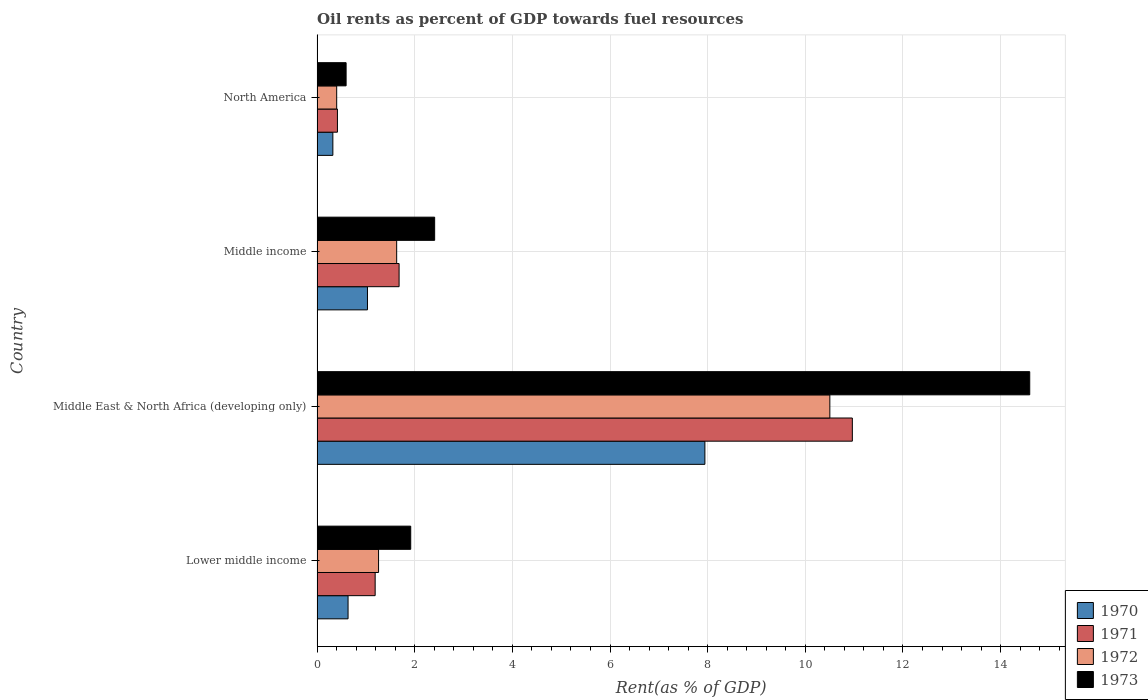How many bars are there on the 2nd tick from the top?
Provide a short and direct response. 4. How many bars are there on the 4th tick from the bottom?
Your answer should be very brief. 4. What is the label of the 4th group of bars from the top?
Your answer should be very brief. Lower middle income. What is the oil rent in 1970 in Lower middle income?
Your response must be concise. 0.63. Across all countries, what is the maximum oil rent in 1973?
Provide a short and direct response. 14.6. Across all countries, what is the minimum oil rent in 1972?
Provide a succinct answer. 0.4. In which country was the oil rent in 1973 maximum?
Offer a very short reply. Middle East & North Africa (developing only). In which country was the oil rent in 1971 minimum?
Your response must be concise. North America. What is the total oil rent in 1970 in the graph?
Give a very brief answer. 9.93. What is the difference between the oil rent in 1970 in Lower middle income and that in North America?
Provide a short and direct response. 0.31. What is the difference between the oil rent in 1973 in North America and the oil rent in 1971 in Middle East & North Africa (developing only)?
Your answer should be compact. -10.37. What is the average oil rent in 1970 per country?
Offer a terse response. 2.48. What is the difference between the oil rent in 1971 and oil rent in 1972 in North America?
Keep it short and to the point. 0.02. In how many countries, is the oil rent in 1972 greater than 7.6 %?
Provide a short and direct response. 1. What is the ratio of the oil rent in 1970 in Lower middle income to that in Middle East & North Africa (developing only)?
Offer a terse response. 0.08. What is the difference between the highest and the second highest oil rent in 1973?
Make the answer very short. 12.19. What is the difference between the highest and the lowest oil rent in 1972?
Keep it short and to the point. 10.1. Is the sum of the oil rent in 1971 in Lower middle income and North America greater than the maximum oil rent in 1972 across all countries?
Keep it short and to the point. No. Is it the case that in every country, the sum of the oil rent in 1973 and oil rent in 1972 is greater than the sum of oil rent in 1971 and oil rent in 1970?
Offer a terse response. No. What does the 1st bar from the top in Middle East & North Africa (developing only) represents?
Provide a succinct answer. 1973. How many bars are there?
Provide a succinct answer. 16. Does the graph contain grids?
Your answer should be very brief. Yes. What is the title of the graph?
Keep it short and to the point. Oil rents as percent of GDP towards fuel resources. Does "2007" appear as one of the legend labels in the graph?
Offer a very short reply. No. What is the label or title of the X-axis?
Make the answer very short. Rent(as % of GDP). What is the label or title of the Y-axis?
Offer a very short reply. Country. What is the Rent(as % of GDP) of 1970 in Lower middle income?
Provide a short and direct response. 0.63. What is the Rent(as % of GDP) of 1971 in Lower middle income?
Keep it short and to the point. 1.19. What is the Rent(as % of GDP) of 1972 in Lower middle income?
Give a very brief answer. 1.26. What is the Rent(as % of GDP) in 1973 in Lower middle income?
Your answer should be very brief. 1.92. What is the Rent(as % of GDP) of 1970 in Middle East & North Africa (developing only)?
Make the answer very short. 7.94. What is the Rent(as % of GDP) in 1971 in Middle East & North Africa (developing only)?
Keep it short and to the point. 10.96. What is the Rent(as % of GDP) of 1972 in Middle East & North Africa (developing only)?
Offer a very short reply. 10.5. What is the Rent(as % of GDP) in 1973 in Middle East & North Africa (developing only)?
Ensure brevity in your answer.  14.6. What is the Rent(as % of GDP) in 1970 in Middle income?
Your answer should be compact. 1.03. What is the Rent(as % of GDP) in 1971 in Middle income?
Provide a short and direct response. 1.68. What is the Rent(as % of GDP) of 1972 in Middle income?
Your response must be concise. 1.63. What is the Rent(as % of GDP) in 1973 in Middle income?
Your response must be concise. 2.41. What is the Rent(as % of GDP) in 1970 in North America?
Give a very brief answer. 0.32. What is the Rent(as % of GDP) in 1971 in North America?
Your answer should be compact. 0.42. What is the Rent(as % of GDP) in 1972 in North America?
Your answer should be very brief. 0.4. What is the Rent(as % of GDP) of 1973 in North America?
Ensure brevity in your answer.  0.6. Across all countries, what is the maximum Rent(as % of GDP) in 1970?
Ensure brevity in your answer.  7.94. Across all countries, what is the maximum Rent(as % of GDP) in 1971?
Your answer should be compact. 10.96. Across all countries, what is the maximum Rent(as % of GDP) of 1972?
Keep it short and to the point. 10.5. Across all countries, what is the maximum Rent(as % of GDP) in 1973?
Offer a terse response. 14.6. Across all countries, what is the minimum Rent(as % of GDP) in 1970?
Provide a short and direct response. 0.32. Across all countries, what is the minimum Rent(as % of GDP) in 1971?
Offer a terse response. 0.42. Across all countries, what is the minimum Rent(as % of GDP) of 1972?
Your answer should be compact. 0.4. Across all countries, what is the minimum Rent(as % of GDP) of 1973?
Your answer should be very brief. 0.6. What is the total Rent(as % of GDP) in 1970 in the graph?
Make the answer very short. 9.93. What is the total Rent(as % of GDP) of 1971 in the graph?
Keep it short and to the point. 14.25. What is the total Rent(as % of GDP) of 1972 in the graph?
Your response must be concise. 13.8. What is the total Rent(as % of GDP) of 1973 in the graph?
Offer a very short reply. 19.52. What is the difference between the Rent(as % of GDP) in 1970 in Lower middle income and that in Middle East & North Africa (developing only)?
Provide a short and direct response. -7.31. What is the difference between the Rent(as % of GDP) in 1971 in Lower middle income and that in Middle East & North Africa (developing only)?
Provide a short and direct response. -9.77. What is the difference between the Rent(as % of GDP) of 1972 in Lower middle income and that in Middle East & North Africa (developing only)?
Provide a succinct answer. -9.24. What is the difference between the Rent(as % of GDP) of 1973 in Lower middle income and that in Middle East & North Africa (developing only)?
Your answer should be very brief. -12.68. What is the difference between the Rent(as % of GDP) in 1970 in Lower middle income and that in Middle income?
Give a very brief answer. -0.4. What is the difference between the Rent(as % of GDP) in 1971 in Lower middle income and that in Middle income?
Your response must be concise. -0.49. What is the difference between the Rent(as % of GDP) in 1972 in Lower middle income and that in Middle income?
Offer a terse response. -0.37. What is the difference between the Rent(as % of GDP) in 1973 in Lower middle income and that in Middle income?
Make the answer very short. -0.49. What is the difference between the Rent(as % of GDP) in 1970 in Lower middle income and that in North America?
Offer a very short reply. 0.31. What is the difference between the Rent(as % of GDP) of 1971 in Lower middle income and that in North America?
Your answer should be compact. 0.77. What is the difference between the Rent(as % of GDP) in 1972 in Lower middle income and that in North America?
Provide a succinct answer. 0.86. What is the difference between the Rent(as % of GDP) of 1973 in Lower middle income and that in North America?
Provide a succinct answer. 1.32. What is the difference between the Rent(as % of GDP) in 1970 in Middle East & North Africa (developing only) and that in Middle income?
Provide a succinct answer. 6.91. What is the difference between the Rent(as % of GDP) of 1971 in Middle East & North Africa (developing only) and that in Middle income?
Give a very brief answer. 9.28. What is the difference between the Rent(as % of GDP) of 1972 in Middle East & North Africa (developing only) and that in Middle income?
Give a very brief answer. 8.87. What is the difference between the Rent(as % of GDP) in 1973 in Middle East & North Africa (developing only) and that in Middle income?
Offer a very short reply. 12.19. What is the difference between the Rent(as % of GDP) in 1970 in Middle East & North Africa (developing only) and that in North America?
Provide a succinct answer. 7.62. What is the difference between the Rent(as % of GDP) of 1971 in Middle East & North Africa (developing only) and that in North America?
Ensure brevity in your answer.  10.55. What is the difference between the Rent(as % of GDP) of 1972 in Middle East & North Africa (developing only) and that in North America?
Ensure brevity in your answer.  10.1. What is the difference between the Rent(as % of GDP) in 1973 in Middle East & North Africa (developing only) and that in North America?
Provide a short and direct response. 14. What is the difference between the Rent(as % of GDP) of 1970 in Middle income and that in North America?
Your response must be concise. 0.71. What is the difference between the Rent(as % of GDP) in 1971 in Middle income and that in North America?
Your answer should be very brief. 1.26. What is the difference between the Rent(as % of GDP) of 1972 in Middle income and that in North America?
Your answer should be very brief. 1.23. What is the difference between the Rent(as % of GDP) in 1973 in Middle income and that in North America?
Make the answer very short. 1.81. What is the difference between the Rent(as % of GDP) in 1970 in Lower middle income and the Rent(as % of GDP) in 1971 in Middle East & North Africa (developing only)?
Make the answer very short. -10.33. What is the difference between the Rent(as % of GDP) of 1970 in Lower middle income and the Rent(as % of GDP) of 1972 in Middle East & North Africa (developing only)?
Give a very brief answer. -9.87. What is the difference between the Rent(as % of GDP) of 1970 in Lower middle income and the Rent(as % of GDP) of 1973 in Middle East & North Africa (developing only)?
Offer a very short reply. -13.96. What is the difference between the Rent(as % of GDP) in 1971 in Lower middle income and the Rent(as % of GDP) in 1972 in Middle East & North Africa (developing only)?
Offer a terse response. -9.31. What is the difference between the Rent(as % of GDP) of 1971 in Lower middle income and the Rent(as % of GDP) of 1973 in Middle East & North Africa (developing only)?
Make the answer very short. -13.41. What is the difference between the Rent(as % of GDP) in 1972 in Lower middle income and the Rent(as % of GDP) in 1973 in Middle East & North Africa (developing only)?
Your response must be concise. -13.34. What is the difference between the Rent(as % of GDP) in 1970 in Lower middle income and the Rent(as % of GDP) in 1971 in Middle income?
Your answer should be very brief. -1.05. What is the difference between the Rent(as % of GDP) in 1970 in Lower middle income and the Rent(as % of GDP) in 1972 in Middle income?
Your response must be concise. -1. What is the difference between the Rent(as % of GDP) of 1970 in Lower middle income and the Rent(as % of GDP) of 1973 in Middle income?
Provide a short and direct response. -1.77. What is the difference between the Rent(as % of GDP) in 1971 in Lower middle income and the Rent(as % of GDP) in 1972 in Middle income?
Your answer should be compact. -0.44. What is the difference between the Rent(as % of GDP) in 1971 in Lower middle income and the Rent(as % of GDP) in 1973 in Middle income?
Ensure brevity in your answer.  -1.22. What is the difference between the Rent(as % of GDP) in 1972 in Lower middle income and the Rent(as % of GDP) in 1973 in Middle income?
Give a very brief answer. -1.15. What is the difference between the Rent(as % of GDP) of 1970 in Lower middle income and the Rent(as % of GDP) of 1971 in North America?
Provide a succinct answer. 0.22. What is the difference between the Rent(as % of GDP) in 1970 in Lower middle income and the Rent(as % of GDP) in 1972 in North America?
Ensure brevity in your answer.  0.23. What is the difference between the Rent(as % of GDP) of 1970 in Lower middle income and the Rent(as % of GDP) of 1973 in North America?
Ensure brevity in your answer.  0.04. What is the difference between the Rent(as % of GDP) of 1971 in Lower middle income and the Rent(as % of GDP) of 1972 in North America?
Offer a very short reply. 0.79. What is the difference between the Rent(as % of GDP) of 1971 in Lower middle income and the Rent(as % of GDP) of 1973 in North America?
Offer a terse response. 0.6. What is the difference between the Rent(as % of GDP) of 1972 in Lower middle income and the Rent(as % of GDP) of 1973 in North America?
Offer a very short reply. 0.66. What is the difference between the Rent(as % of GDP) of 1970 in Middle East & North Africa (developing only) and the Rent(as % of GDP) of 1971 in Middle income?
Your response must be concise. 6.26. What is the difference between the Rent(as % of GDP) of 1970 in Middle East & North Africa (developing only) and the Rent(as % of GDP) of 1972 in Middle income?
Give a very brief answer. 6.31. What is the difference between the Rent(as % of GDP) in 1970 in Middle East & North Africa (developing only) and the Rent(as % of GDP) in 1973 in Middle income?
Make the answer very short. 5.53. What is the difference between the Rent(as % of GDP) of 1971 in Middle East & North Africa (developing only) and the Rent(as % of GDP) of 1972 in Middle income?
Make the answer very short. 9.33. What is the difference between the Rent(as % of GDP) in 1971 in Middle East & North Africa (developing only) and the Rent(as % of GDP) in 1973 in Middle income?
Offer a terse response. 8.55. What is the difference between the Rent(as % of GDP) in 1972 in Middle East & North Africa (developing only) and the Rent(as % of GDP) in 1973 in Middle income?
Provide a succinct answer. 8.09. What is the difference between the Rent(as % of GDP) of 1970 in Middle East & North Africa (developing only) and the Rent(as % of GDP) of 1971 in North America?
Your answer should be very brief. 7.53. What is the difference between the Rent(as % of GDP) of 1970 in Middle East & North Africa (developing only) and the Rent(as % of GDP) of 1972 in North America?
Ensure brevity in your answer.  7.54. What is the difference between the Rent(as % of GDP) of 1970 in Middle East & North Africa (developing only) and the Rent(as % of GDP) of 1973 in North America?
Ensure brevity in your answer.  7.35. What is the difference between the Rent(as % of GDP) in 1971 in Middle East & North Africa (developing only) and the Rent(as % of GDP) in 1972 in North America?
Your response must be concise. 10.56. What is the difference between the Rent(as % of GDP) of 1971 in Middle East & North Africa (developing only) and the Rent(as % of GDP) of 1973 in North America?
Make the answer very short. 10.37. What is the difference between the Rent(as % of GDP) of 1972 in Middle East & North Africa (developing only) and the Rent(as % of GDP) of 1973 in North America?
Give a very brief answer. 9.91. What is the difference between the Rent(as % of GDP) in 1970 in Middle income and the Rent(as % of GDP) in 1971 in North America?
Keep it short and to the point. 0.61. What is the difference between the Rent(as % of GDP) in 1970 in Middle income and the Rent(as % of GDP) in 1972 in North America?
Make the answer very short. 0.63. What is the difference between the Rent(as % of GDP) in 1970 in Middle income and the Rent(as % of GDP) in 1973 in North America?
Give a very brief answer. 0.44. What is the difference between the Rent(as % of GDP) of 1971 in Middle income and the Rent(as % of GDP) of 1972 in North America?
Ensure brevity in your answer.  1.28. What is the difference between the Rent(as % of GDP) of 1971 in Middle income and the Rent(as % of GDP) of 1973 in North America?
Ensure brevity in your answer.  1.09. What is the difference between the Rent(as % of GDP) of 1972 in Middle income and the Rent(as % of GDP) of 1973 in North America?
Offer a terse response. 1.04. What is the average Rent(as % of GDP) of 1970 per country?
Make the answer very short. 2.48. What is the average Rent(as % of GDP) of 1971 per country?
Give a very brief answer. 3.56. What is the average Rent(as % of GDP) in 1972 per country?
Offer a terse response. 3.45. What is the average Rent(as % of GDP) in 1973 per country?
Your answer should be compact. 4.88. What is the difference between the Rent(as % of GDP) of 1970 and Rent(as % of GDP) of 1971 in Lower middle income?
Provide a short and direct response. -0.56. What is the difference between the Rent(as % of GDP) of 1970 and Rent(as % of GDP) of 1972 in Lower middle income?
Offer a terse response. -0.62. What is the difference between the Rent(as % of GDP) of 1970 and Rent(as % of GDP) of 1973 in Lower middle income?
Provide a succinct answer. -1.28. What is the difference between the Rent(as % of GDP) in 1971 and Rent(as % of GDP) in 1972 in Lower middle income?
Your response must be concise. -0.07. What is the difference between the Rent(as % of GDP) in 1971 and Rent(as % of GDP) in 1973 in Lower middle income?
Give a very brief answer. -0.73. What is the difference between the Rent(as % of GDP) in 1972 and Rent(as % of GDP) in 1973 in Lower middle income?
Make the answer very short. -0.66. What is the difference between the Rent(as % of GDP) in 1970 and Rent(as % of GDP) in 1971 in Middle East & North Africa (developing only)?
Make the answer very short. -3.02. What is the difference between the Rent(as % of GDP) of 1970 and Rent(as % of GDP) of 1972 in Middle East & North Africa (developing only)?
Your answer should be very brief. -2.56. What is the difference between the Rent(as % of GDP) in 1970 and Rent(as % of GDP) in 1973 in Middle East & North Africa (developing only)?
Ensure brevity in your answer.  -6.65. What is the difference between the Rent(as % of GDP) of 1971 and Rent(as % of GDP) of 1972 in Middle East & North Africa (developing only)?
Give a very brief answer. 0.46. What is the difference between the Rent(as % of GDP) in 1971 and Rent(as % of GDP) in 1973 in Middle East & North Africa (developing only)?
Offer a terse response. -3.63. What is the difference between the Rent(as % of GDP) in 1972 and Rent(as % of GDP) in 1973 in Middle East & North Africa (developing only)?
Give a very brief answer. -4.09. What is the difference between the Rent(as % of GDP) in 1970 and Rent(as % of GDP) in 1971 in Middle income?
Your answer should be very brief. -0.65. What is the difference between the Rent(as % of GDP) of 1970 and Rent(as % of GDP) of 1972 in Middle income?
Make the answer very short. -0.6. What is the difference between the Rent(as % of GDP) in 1970 and Rent(as % of GDP) in 1973 in Middle income?
Offer a very short reply. -1.38. What is the difference between the Rent(as % of GDP) of 1971 and Rent(as % of GDP) of 1972 in Middle income?
Keep it short and to the point. 0.05. What is the difference between the Rent(as % of GDP) in 1971 and Rent(as % of GDP) in 1973 in Middle income?
Offer a terse response. -0.73. What is the difference between the Rent(as % of GDP) of 1972 and Rent(as % of GDP) of 1973 in Middle income?
Your answer should be very brief. -0.78. What is the difference between the Rent(as % of GDP) of 1970 and Rent(as % of GDP) of 1971 in North America?
Your answer should be very brief. -0.09. What is the difference between the Rent(as % of GDP) in 1970 and Rent(as % of GDP) in 1972 in North America?
Your answer should be very brief. -0.08. What is the difference between the Rent(as % of GDP) of 1970 and Rent(as % of GDP) of 1973 in North America?
Ensure brevity in your answer.  -0.27. What is the difference between the Rent(as % of GDP) in 1971 and Rent(as % of GDP) in 1972 in North America?
Your answer should be very brief. 0.02. What is the difference between the Rent(as % of GDP) in 1971 and Rent(as % of GDP) in 1973 in North America?
Offer a terse response. -0.18. What is the difference between the Rent(as % of GDP) of 1972 and Rent(as % of GDP) of 1973 in North America?
Offer a very short reply. -0.19. What is the ratio of the Rent(as % of GDP) in 1970 in Lower middle income to that in Middle East & North Africa (developing only)?
Offer a very short reply. 0.08. What is the ratio of the Rent(as % of GDP) in 1971 in Lower middle income to that in Middle East & North Africa (developing only)?
Make the answer very short. 0.11. What is the ratio of the Rent(as % of GDP) of 1972 in Lower middle income to that in Middle East & North Africa (developing only)?
Keep it short and to the point. 0.12. What is the ratio of the Rent(as % of GDP) in 1973 in Lower middle income to that in Middle East & North Africa (developing only)?
Ensure brevity in your answer.  0.13. What is the ratio of the Rent(as % of GDP) in 1970 in Lower middle income to that in Middle income?
Your answer should be very brief. 0.61. What is the ratio of the Rent(as % of GDP) in 1971 in Lower middle income to that in Middle income?
Give a very brief answer. 0.71. What is the ratio of the Rent(as % of GDP) of 1972 in Lower middle income to that in Middle income?
Offer a terse response. 0.77. What is the ratio of the Rent(as % of GDP) of 1973 in Lower middle income to that in Middle income?
Your response must be concise. 0.8. What is the ratio of the Rent(as % of GDP) in 1970 in Lower middle income to that in North America?
Provide a short and direct response. 1.96. What is the ratio of the Rent(as % of GDP) in 1971 in Lower middle income to that in North America?
Your answer should be very brief. 2.85. What is the ratio of the Rent(as % of GDP) in 1972 in Lower middle income to that in North America?
Provide a succinct answer. 3.13. What is the ratio of the Rent(as % of GDP) of 1973 in Lower middle income to that in North America?
Give a very brief answer. 3.22. What is the ratio of the Rent(as % of GDP) in 1970 in Middle East & North Africa (developing only) to that in Middle income?
Provide a short and direct response. 7.69. What is the ratio of the Rent(as % of GDP) of 1971 in Middle East & North Africa (developing only) to that in Middle income?
Offer a very short reply. 6.52. What is the ratio of the Rent(as % of GDP) of 1972 in Middle East & North Africa (developing only) to that in Middle income?
Give a very brief answer. 6.44. What is the ratio of the Rent(as % of GDP) of 1973 in Middle East & North Africa (developing only) to that in Middle income?
Provide a succinct answer. 6.06. What is the ratio of the Rent(as % of GDP) in 1970 in Middle East & North Africa (developing only) to that in North America?
Your answer should be very brief. 24.54. What is the ratio of the Rent(as % of GDP) of 1971 in Middle East & North Africa (developing only) to that in North America?
Offer a very short reply. 26.26. What is the ratio of the Rent(as % of GDP) of 1972 in Middle East & North Africa (developing only) to that in North America?
Give a very brief answer. 26.11. What is the ratio of the Rent(as % of GDP) of 1973 in Middle East & North Africa (developing only) to that in North America?
Make the answer very short. 24.53. What is the ratio of the Rent(as % of GDP) in 1970 in Middle income to that in North America?
Offer a very short reply. 3.19. What is the ratio of the Rent(as % of GDP) of 1971 in Middle income to that in North America?
Your answer should be compact. 4.03. What is the ratio of the Rent(as % of GDP) of 1972 in Middle income to that in North America?
Offer a terse response. 4.05. What is the ratio of the Rent(as % of GDP) in 1973 in Middle income to that in North America?
Offer a terse response. 4.05. What is the difference between the highest and the second highest Rent(as % of GDP) in 1970?
Provide a short and direct response. 6.91. What is the difference between the highest and the second highest Rent(as % of GDP) in 1971?
Offer a very short reply. 9.28. What is the difference between the highest and the second highest Rent(as % of GDP) of 1972?
Keep it short and to the point. 8.87. What is the difference between the highest and the second highest Rent(as % of GDP) of 1973?
Offer a very short reply. 12.19. What is the difference between the highest and the lowest Rent(as % of GDP) in 1970?
Offer a very short reply. 7.62. What is the difference between the highest and the lowest Rent(as % of GDP) of 1971?
Your answer should be compact. 10.55. What is the difference between the highest and the lowest Rent(as % of GDP) of 1972?
Offer a terse response. 10.1. What is the difference between the highest and the lowest Rent(as % of GDP) of 1973?
Offer a terse response. 14. 